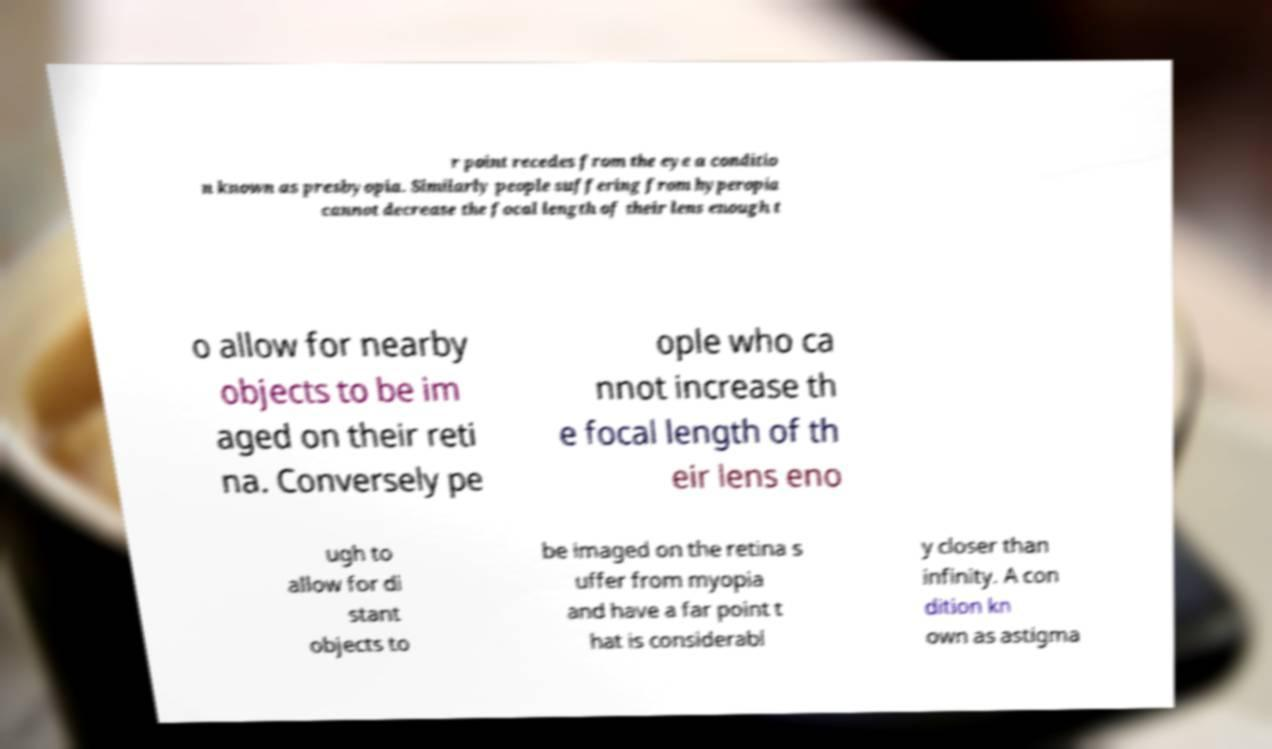Could you extract and type out the text from this image? r point recedes from the eye a conditio n known as presbyopia. Similarly people suffering from hyperopia cannot decrease the focal length of their lens enough t o allow for nearby objects to be im aged on their reti na. Conversely pe ople who ca nnot increase th e focal length of th eir lens eno ugh to allow for di stant objects to be imaged on the retina s uffer from myopia and have a far point t hat is considerabl y closer than infinity. A con dition kn own as astigma 